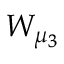<formula> <loc_0><loc_0><loc_500><loc_500>W _ { \mu _ { 3 } }</formula> 